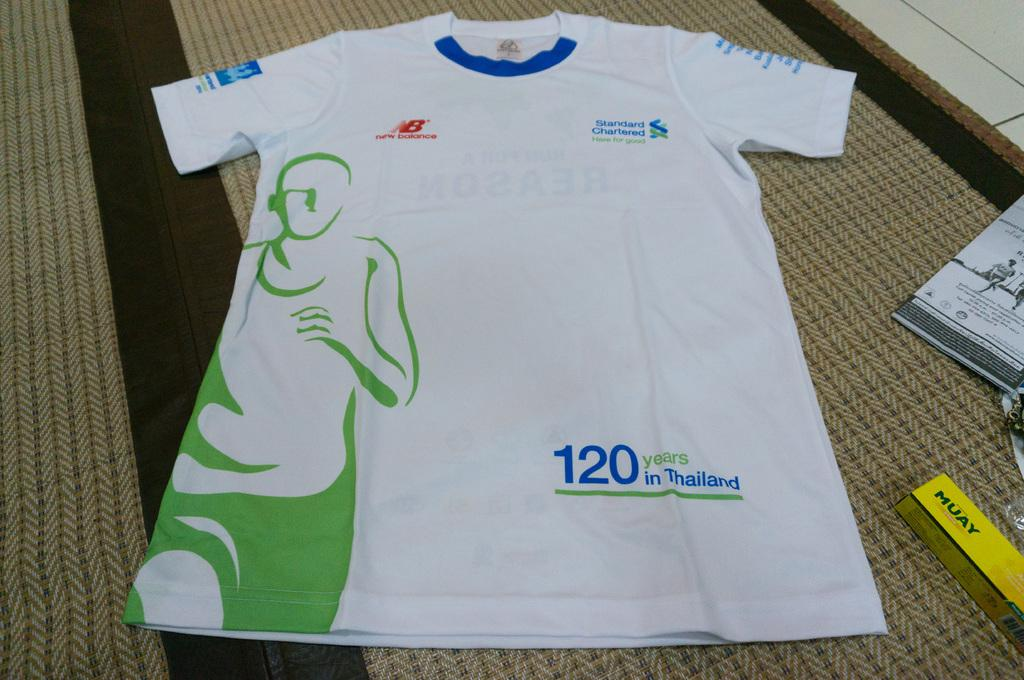<image>
Share a concise interpretation of the image provided. the number 120 is on the white shirt 